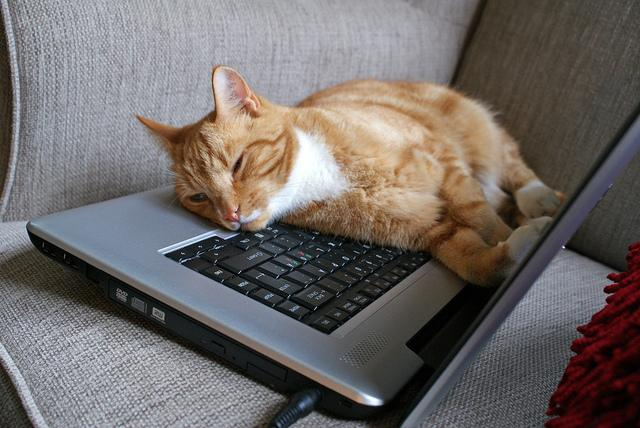Why is the cat likely sleeping on the laptop? tired 